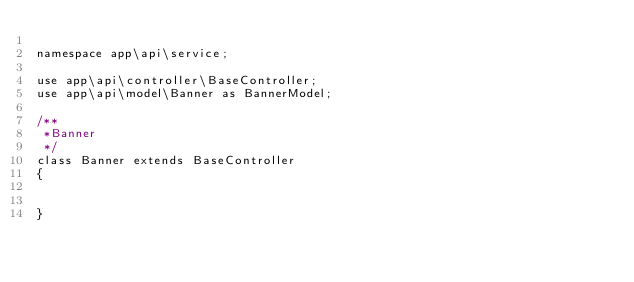<code> <loc_0><loc_0><loc_500><loc_500><_PHP_>
namespace app\api\service;

use app\api\controller\BaseController;
use app\api\model\Banner as BannerModel;

/**
 *Banner
 */
class Banner extends BaseController
{
    
 
}</code> 